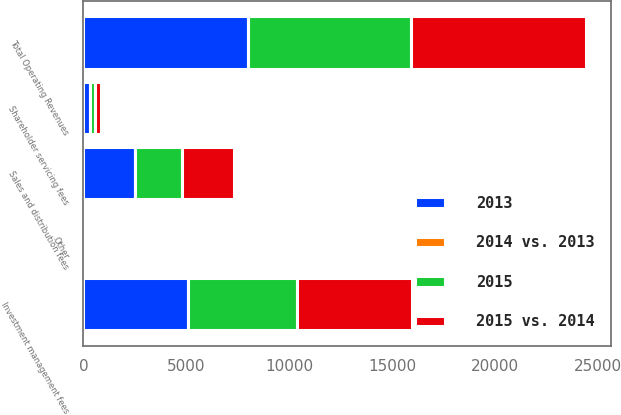Convert chart. <chart><loc_0><loc_0><loc_500><loc_500><stacked_bar_chart><ecel><fcel>Investment management fees<fcel>Sales and distribution fees<fcel>Shareholder servicing fees<fcel>Other<fcel>Total Operating Revenues<nl><fcel>2015<fcel>5327.8<fcel>2252.4<fcel>262.8<fcel>105.7<fcel>7948.7<nl><fcel>2015 vs. 2014<fcel>5565.7<fcel>2546.4<fcel>281.1<fcel>98.2<fcel>8491.4<nl><fcel>2013<fcel>5071.4<fcel>2516<fcel>303.7<fcel>93.9<fcel>7985<nl><fcel>2014 vs. 2013<fcel>4<fcel>12<fcel>7<fcel>8<fcel>6<nl></chart> 